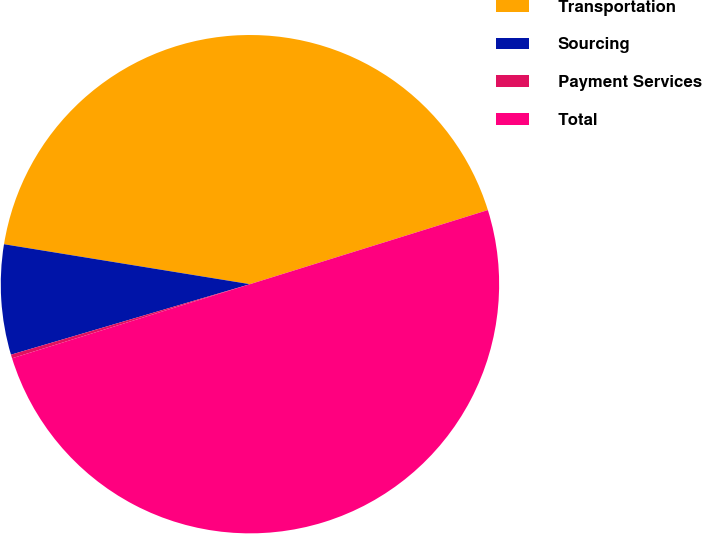<chart> <loc_0><loc_0><loc_500><loc_500><pie_chart><fcel>Transportation<fcel>Sourcing<fcel>Payment Services<fcel>Total<nl><fcel>42.63%<fcel>7.13%<fcel>0.24%<fcel>50.0%<nl></chart> 